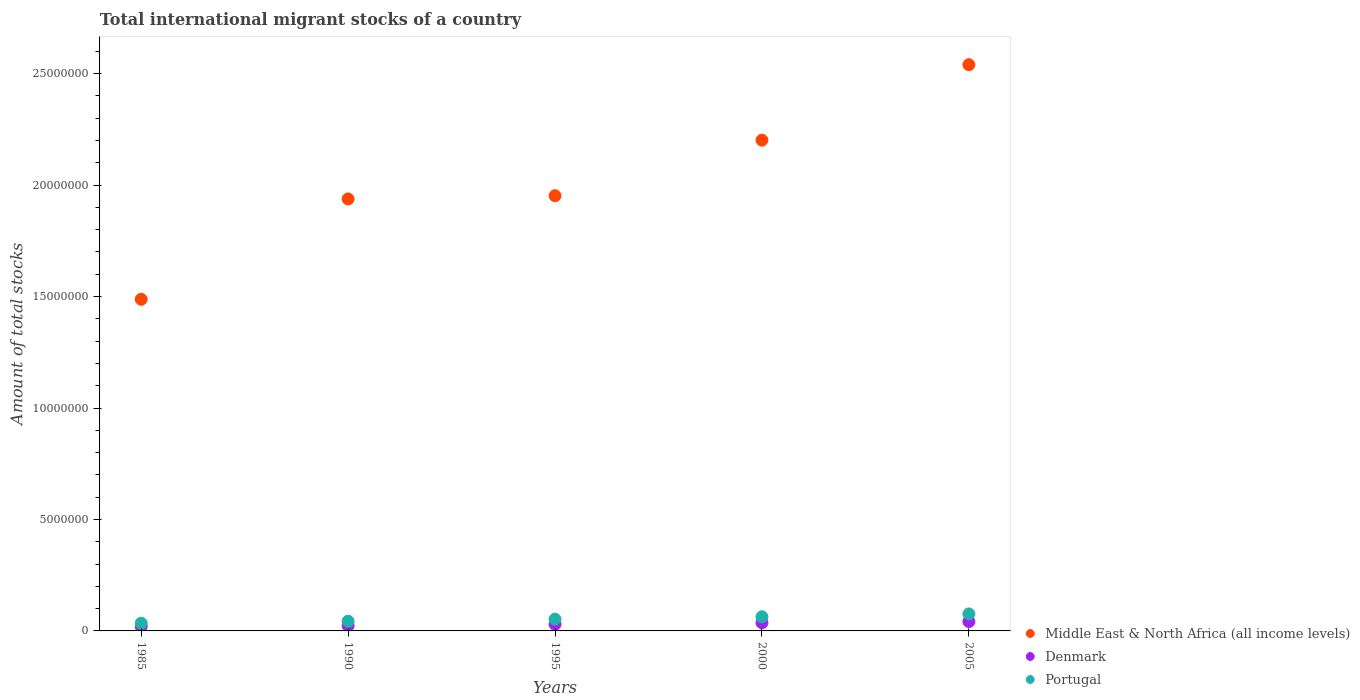How many different coloured dotlines are there?
Provide a short and direct response. 3. Is the number of dotlines equal to the number of legend labels?
Your answer should be compact. Yes. What is the amount of total stocks in in Middle East & North Africa (all income levels) in 1995?
Offer a very short reply. 1.95e+07. Across all years, what is the maximum amount of total stocks in in Denmark?
Make the answer very short. 4.21e+05. Across all years, what is the minimum amount of total stocks in in Middle East & North Africa (all income levels)?
Offer a very short reply. 1.49e+07. In which year was the amount of total stocks in in Portugal maximum?
Make the answer very short. 2005. In which year was the amount of total stocks in in Middle East & North Africa (all income levels) minimum?
Your answer should be compact. 1985. What is the total amount of total stocks in in Middle East & North Africa (all income levels) in the graph?
Ensure brevity in your answer.  1.01e+08. What is the difference between the amount of total stocks in in Portugal in 1990 and that in 2005?
Your answer should be very brief. -3.28e+05. What is the difference between the amount of total stocks in in Middle East & North Africa (all income levels) in 1985 and the amount of total stocks in in Portugal in 1995?
Ensure brevity in your answer.  1.43e+07. What is the average amount of total stocks in in Denmark per year?
Provide a short and direct response. 3.04e+05. In the year 2000, what is the difference between the amount of total stocks in in Portugal and amount of total stocks in in Middle East & North Africa (all income levels)?
Keep it short and to the point. -2.14e+07. In how many years, is the amount of total stocks in in Portugal greater than 16000000?
Your answer should be compact. 0. What is the ratio of the amount of total stocks in in Denmark in 1985 to that in 2000?
Your response must be concise. 0.53. Is the amount of total stocks in in Middle East & North Africa (all income levels) in 1985 less than that in 1995?
Your answer should be compact. Yes. What is the difference between the highest and the second highest amount of total stocks in in Denmark?
Give a very brief answer. 4.98e+04. What is the difference between the highest and the lowest amount of total stocks in in Middle East & North Africa (all income levels)?
Your answer should be compact. 1.05e+07. Is the sum of the amount of total stocks in in Portugal in 2000 and 2005 greater than the maximum amount of total stocks in in Middle East & North Africa (all income levels) across all years?
Offer a terse response. No. Are the values on the major ticks of Y-axis written in scientific E-notation?
Your response must be concise. No. Does the graph contain any zero values?
Ensure brevity in your answer.  No. Does the graph contain grids?
Your response must be concise. No. Where does the legend appear in the graph?
Your response must be concise. Bottom right. How many legend labels are there?
Ensure brevity in your answer.  3. What is the title of the graph?
Make the answer very short. Total international migrant stocks of a country. Does "Brazil" appear as one of the legend labels in the graph?
Your answer should be very brief. No. What is the label or title of the X-axis?
Your answer should be very brief. Years. What is the label or title of the Y-axis?
Ensure brevity in your answer.  Amount of total stocks. What is the Amount of total stocks of Middle East & North Africa (all income levels) in 1985?
Offer a very short reply. 1.49e+07. What is the Amount of total stocks of Denmark in 1985?
Keep it short and to the point. 1.96e+05. What is the Amount of total stocks in Portugal in 1985?
Your answer should be very brief. 3.46e+05. What is the Amount of total stocks of Middle East & North Africa (all income levels) in 1990?
Provide a succinct answer. 1.94e+07. What is the Amount of total stocks of Denmark in 1990?
Offer a terse response. 2.35e+05. What is the Amount of total stocks in Portugal in 1990?
Your response must be concise. 4.36e+05. What is the Amount of total stocks of Middle East & North Africa (all income levels) in 1995?
Provide a succinct answer. 1.95e+07. What is the Amount of total stocks of Denmark in 1995?
Offer a terse response. 2.97e+05. What is the Amount of total stocks of Portugal in 1995?
Your answer should be very brief. 5.28e+05. What is the Amount of total stocks of Middle East & North Africa (all income levels) in 2000?
Keep it short and to the point. 2.20e+07. What is the Amount of total stocks in Denmark in 2000?
Make the answer very short. 3.71e+05. What is the Amount of total stocks in Portugal in 2000?
Offer a very short reply. 6.35e+05. What is the Amount of total stocks in Middle East & North Africa (all income levels) in 2005?
Offer a terse response. 2.54e+07. What is the Amount of total stocks in Denmark in 2005?
Your answer should be very brief. 4.21e+05. What is the Amount of total stocks in Portugal in 2005?
Keep it short and to the point. 7.64e+05. Across all years, what is the maximum Amount of total stocks in Middle East & North Africa (all income levels)?
Make the answer very short. 2.54e+07. Across all years, what is the maximum Amount of total stocks of Denmark?
Keep it short and to the point. 4.21e+05. Across all years, what is the maximum Amount of total stocks in Portugal?
Make the answer very short. 7.64e+05. Across all years, what is the minimum Amount of total stocks in Middle East & North Africa (all income levels)?
Your answer should be very brief. 1.49e+07. Across all years, what is the minimum Amount of total stocks of Denmark?
Your response must be concise. 1.96e+05. Across all years, what is the minimum Amount of total stocks of Portugal?
Your answer should be very brief. 3.46e+05. What is the total Amount of total stocks in Middle East & North Africa (all income levels) in the graph?
Provide a short and direct response. 1.01e+08. What is the total Amount of total stocks in Denmark in the graph?
Keep it short and to the point. 1.52e+06. What is the total Amount of total stocks in Portugal in the graph?
Offer a terse response. 2.71e+06. What is the difference between the Amount of total stocks in Middle East & North Africa (all income levels) in 1985 and that in 1990?
Your answer should be very brief. -4.50e+06. What is the difference between the Amount of total stocks in Denmark in 1985 and that in 1990?
Provide a short and direct response. -3.94e+04. What is the difference between the Amount of total stocks in Portugal in 1985 and that in 1990?
Keep it short and to the point. -8.96e+04. What is the difference between the Amount of total stocks in Middle East & North Africa (all income levels) in 1985 and that in 1995?
Your answer should be very brief. -4.65e+06. What is the difference between the Amount of total stocks of Denmark in 1985 and that in 1995?
Ensure brevity in your answer.  -1.02e+05. What is the difference between the Amount of total stocks of Portugal in 1985 and that in 1995?
Your response must be concise. -1.82e+05. What is the difference between the Amount of total stocks of Middle East & North Africa (all income levels) in 1985 and that in 2000?
Provide a succinct answer. -7.14e+06. What is the difference between the Amount of total stocks of Denmark in 1985 and that in 2000?
Offer a very short reply. -1.75e+05. What is the difference between the Amount of total stocks in Portugal in 1985 and that in 2000?
Make the answer very short. -2.89e+05. What is the difference between the Amount of total stocks in Middle East & North Africa (all income levels) in 1985 and that in 2005?
Ensure brevity in your answer.  -1.05e+07. What is the difference between the Amount of total stocks of Denmark in 1985 and that in 2005?
Provide a succinct answer. -2.25e+05. What is the difference between the Amount of total stocks in Portugal in 1985 and that in 2005?
Give a very brief answer. -4.18e+05. What is the difference between the Amount of total stocks in Middle East & North Africa (all income levels) in 1990 and that in 1995?
Your answer should be compact. -1.44e+05. What is the difference between the Amount of total stocks in Denmark in 1990 and that in 1995?
Give a very brief answer. -6.22e+04. What is the difference between the Amount of total stocks of Portugal in 1990 and that in 1995?
Your response must be concise. -9.21e+04. What is the difference between the Amount of total stocks of Middle East & North Africa (all income levels) in 1990 and that in 2000?
Keep it short and to the point. -2.64e+06. What is the difference between the Amount of total stocks in Denmark in 1990 and that in 2000?
Provide a short and direct response. -1.36e+05. What is the difference between the Amount of total stocks of Portugal in 1990 and that in 2000?
Ensure brevity in your answer.  -1.99e+05. What is the difference between the Amount of total stocks of Middle East & North Africa (all income levels) in 1990 and that in 2005?
Your answer should be compact. -6.02e+06. What is the difference between the Amount of total stocks in Denmark in 1990 and that in 2005?
Provide a succinct answer. -1.86e+05. What is the difference between the Amount of total stocks of Portugal in 1990 and that in 2005?
Make the answer very short. -3.28e+05. What is the difference between the Amount of total stocks in Middle East & North Africa (all income levels) in 1995 and that in 2000?
Ensure brevity in your answer.  -2.49e+06. What is the difference between the Amount of total stocks in Denmark in 1995 and that in 2000?
Your answer should be very brief. -7.36e+04. What is the difference between the Amount of total stocks in Portugal in 1995 and that in 2000?
Offer a terse response. -1.07e+05. What is the difference between the Amount of total stocks of Middle East & North Africa (all income levels) in 1995 and that in 2005?
Your response must be concise. -5.88e+06. What is the difference between the Amount of total stocks of Denmark in 1995 and that in 2005?
Your answer should be very brief. -1.23e+05. What is the difference between the Amount of total stocks in Portugal in 1995 and that in 2005?
Make the answer very short. -2.36e+05. What is the difference between the Amount of total stocks in Middle East & North Africa (all income levels) in 2000 and that in 2005?
Offer a very short reply. -3.39e+06. What is the difference between the Amount of total stocks in Denmark in 2000 and that in 2005?
Make the answer very short. -4.98e+04. What is the difference between the Amount of total stocks of Portugal in 2000 and that in 2005?
Ensure brevity in your answer.  -1.29e+05. What is the difference between the Amount of total stocks of Middle East & North Africa (all income levels) in 1985 and the Amount of total stocks of Denmark in 1990?
Offer a very short reply. 1.46e+07. What is the difference between the Amount of total stocks in Middle East & North Africa (all income levels) in 1985 and the Amount of total stocks in Portugal in 1990?
Give a very brief answer. 1.44e+07. What is the difference between the Amount of total stocks of Denmark in 1985 and the Amount of total stocks of Portugal in 1990?
Give a very brief answer. -2.40e+05. What is the difference between the Amount of total stocks in Middle East & North Africa (all income levels) in 1985 and the Amount of total stocks in Denmark in 1995?
Ensure brevity in your answer.  1.46e+07. What is the difference between the Amount of total stocks of Middle East & North Africa (all income levels) in 1985 and the Amount of total stocks of Portugal in 1995?
Provide a succinct answer. 1.43e+07. What is the difference between the Amount of total stocks of Denmark in 1985 and the Amount of total stocks of Portugal in 1995?
Give a very brief answer. -3.32e+05. What is the difference between the Amount of total stocks of Middle East & North Africa (all income levels) in 1985 and the Amount of total stocks of Denmark in 2000?
Give a very brief answer. 1.45e+07. What is the difference between the Amount of total stocks in Middle East & North Africa (all income levels) in 1985 and the Amount of total stocks in Portugal in 2000?
Offer a terse response. 1.42e+07. What is the difference between the Amount of total stocks of Denmark in 1985 and the Amount of total stocks of Portugal in 2000?
Keep it short and to the point. -4.39e+05. What is the difference between the Amount of total stocks in Middle East & North Africa (all income levels) in 1985 and the Amount of total stocks in Denmark in 2005?
Give a very brief answer. 1.45e+07. What is the difference between the Amount of total stocks in Middle East & North Africa (all income levels) in 1985 and the Amount of total stocks in Portugal in 2005?
Ensure brevity in your answer.  1.41e+07. What is the difference between the Amount of total stocks in Denmark in 1985 and the Amount of total stocks in Portugal in 2005?
Your answer should be very brief. -5.68e+05. What is the difference between the Amount of total stocks of Middle East & North Africa (all income levels) in 1990 and the Amount of total stocks of Denmark in 1995?
Keep it short and to the point. 1.91e+07. What is the difference between the Amount of total stocks of Middle East & North Africa (all income levels) in 1990 and the Amount of total stocks of Portugal in 1995?
Your response must be concise. 1.89e+07. What is the difference between the Amount of total stocks of Denmark in 1990 and the Amount of total stocks of Portugal in 1995?
Provide a short and direct response. -2.93e+05. What is the difference between the Amount of total stocks of Middle East & North Africa (all income levels) in 1990 and the Amount of total stocks of Denmark in 2000?
Offer a very short reply. 1.90e+07. What is the difference between the Amount of total stocks in Middle East & North Africa (all income levels) in 1990 and the Amount of total stocks in Portugal in 2000?
Give a very brief answer. 1.87e+07. What is the difference between the Amount of total stocks in Denmark in 1990 and the Amount of total stocks in Portugal in 2000?
Make the answer very short. -4.00e+05. What is the difference between the Amount of total stocks of Middle East & North Africa (all income levels) in 1990 and the Amount of total stocks of Denmark in 2005?
Your answer should be compact. 1.90e+07. What is the difference between the Amount of total stocks of Middle East & North Africa (all income levels) in 1990 and the Amount of total stocks of Portugal in 2005?
Offer a terse response. 1.86e+07. What is the difference between the Amount of total stocks in Denmark in 1990 and the Amount of total stocks in Portugal in 2005?
Provide a succinct answer. -5.29e+05. What is the difference between the Amount of total stocks in Middle East & North Africa (all income levels) in 1995 and the Amount of total stocks in Denmark in 2000?
Your answer should be very brief. 1.92e+07. What is the difference between the Amount of total stocks in Middle East & North Africa (all income levels) in 1995 and the Amount of total stocks in Portugal in 2000?
Ensure brevity in your answer.  1.89e+07. What is the difference between the Amount of total stocks of Denmark in 1995 and the Amount of total stocks of Portugal in 2000?
Your response must be concise. -3.38e+05. What is the difference between the Amount of total stocks in Middle East & North Africa (all income levels) in 1995 and the Amount of total stocks in Denmark in 2005?
Provide a succinct answer. 1.91e+07. What is the difference between the Amount of total stocks in Middle East & North Africa (all income levels) in 1995 and the Amount of total stocks in Portugal in 2005?
Offer a terse response. 1.88e+07. What is the difference between the Amount of total stocks of Denmark in 1995 and the Amount of total stocks of Portugal in 2005?
Your answer should be very brief. -4.66e+05. What is the difference between the Amount of total stocks of Middle East & North Africa (all income levels) in 2000 and the Amount of total stocks of Denmark in 2005?
Keep it short and to the point. 2.16e+07. What is the difference between the Amount of total stocks in Middle East & North Africa (all income levels) in 2000 and the Amount of total stocks in Portugal in 2005?
Provide a short and direct response. 2.13e+07. What is the difference between the Amount of total stocks of Denmark in 2000 and the Amount of total stocks of Portugal in 2005?
Keep it short and to the point. -3.93e+05. What is the average Amount of total stocks of Middle East & North Africa (all income levels) per year?
Offer a very short reply. 2.02e+07. What is the average Amount of total stocks in Denmark per year?
Make the answer very short. 3.04e+05. What is the average Amount of total stocks of Portugal per year?
Give a very brief answer. 5.42e+05. In the year 1985, what is the difference between the Amount of total stocks in Middle East & North Africa (all income levels) and Amount of total stocks in Denmark?
Make the answer very short. 1.47e+07. In the year 1985, what is the difference between the Amount of total stocks of Middle East & North Africa (all income levels) and Amount of total stocks of Portugal?
Your response must be concise. 1.45e+07. In the year 1985, what is the difference between the Amount of total stocks of Denmark and Amount of total stocks of Portugal?
Your answer should be compact. -1.50e+05. In the year 1990, what is the difference between the Amount of total stocks in Middle East & North Africa (all income levels) and Amount of total stocks in Denmark?
Offer a terse response. 1.91e+07. In the year 1990, what is the difference between the Amount of total stocks of Middle East & North Africa (all income levels) and Amount of total stocks of Portugal?
Provide a succinct answer. 1.89e+07. In the year 1990, what is the difference between the Amount of total stocks of Denmark and Amount of total stocks of Portugal?
Make the answer very short. -2.01e+05. In the year 1995, what is the difference between the Amount of total stocks in Middle East & North Africa (all income levels) and Amount of total stocks in Denmark?
Offer a very short reply. 1.92e+07. In the year 1995, what is the difference between the Amount of total stocks in Middle East & North Africa (all income levels) and Amount of total stocks in Portugal?
Give a very brief answer. 1.90e+07. In the year 1995, what is the difference between the Amount of total stocks of Denmark and Amount of total stocks of Portugal?
Keep it short and to the point. -2.31e+05. In the year 2000, what is the difference between the Amount of total stocks of Middle East & North Africa (all income levels) and Amount of total stocks of Denmark?
Ensure brevity in your answer.  2.16e+07. In the year 2000, what is the difference between the Amount of total stocks of Middle East & North Africa (all income levels) and Amount of total stocks of Portugal?
Offer a very short reply. 2.14e+07. In the year 2000, what is the difference between the Amount of total stocks in Denmark and Amount of total stocks in Portugal?
Offer a very short reply. -2.64e+05. In the year 2005, what is the difference between the Amount of total stocks of Middle East & North Africa (all income levels) and Amount of total stocks of Denmark?
Your answer should be compact. 2.50e+07. In the year 2005, what is the difference between the Amount of total stocks of Middle East & North Africa (all income levels) and Amount of total stocks of Portugal?
Offer a very short reply. 2.46e+07. In the year 2005, what is the difference between the Amount of total stocks in Denmark and Amount of total stocks in Portugal?
Your response must be concise. -3.43e+05. What is the ratio of the Amount of total stocks in Middle East & North Africa (all income levels) in 1985 to that in 1990?
Your answer should be compact. 0.77. What is the ratio of the Amount of total stocks in Denmark in 1985 to that in 1990?
Ensure brevity in your answer.  0.83. What is the ratio of the Amount of total stocks in Portugal in 1985 to that in 1990?
Your response must be concise. 0.79. What is the ratio of the Amount of total stocks of Middle East & North Africa (all income levels) in 1985 to that in 1995?
Give a very brief answer. 0.76. What is the ratio of the Amount of total stocks of Denmark in 1985 to that in 1995?
Keep it short and to the point. 0.66. What is the ratio of the Amount of total stocks in Portugal in 1985 to that in 1995?
Offer a terse response. 0.66. What is the ratio of the Amount of total stocks in Middle East & North Africa (all income levels) in 1985 to that in 2000?
Provide a succinct answer. 0.68. What is the ratio of the Amount of total stocks of Denmark in 1985 to that in 2000?
Your answer should be compact. 0.53. What is the ratio of the Amount of total stocks of Portugal in 1985 to that in 2000?
Your answer should be compact. 0.55. What is the ratio of the Amount of total stocks in Middle East & North Africa (all income levels) in 1985 to that in 2005?
Keep it short and to the point. 0.59. What is the ratio of the Amount of total stocks in Denmark in 1985 to that in 2005?
Make the answer very short. 0.47. What is the ratio of the Amount of total stocks in Portugal in 1985 to that in 2005?
Offer a terse response. 0.45. What is the ratio of the Amount of total stocks in Middle East & North Africa (all income levels) in 1990 to that in 1995?
Your response must be concise. 0.99. What is the ratio of the Amount of total stocks in Denmark in 1990 to that in 1995?
Your answer should be very brief. 0.79. What is the ratio of the Amount of total stocks in Portugal in 1990 to that in 1995?
Your response must be concise. 0.83. What is the ratio of the Amount of total stocks in Middle East & North Africa (all income levels) in 1990 to that in 2000?
Your answer should be very brief. 0.88. What is the ratio of the Amount of total stocks of Denmark in 1990 to that in 2000?
Provide a short and direct response. 0.63. What is the ratio of the Amount of total stocks in Portugal in 1990 to that in 2000?
Your response must be concise. 0.69. What is the ratio of the Amount of total stocks of Middle East & North Africa (all income levels) in 1990 to that in 2005?
Your answer should be very brief. 0.76. What is the ratio of the Amount of total stocks of Denmark in 1990 to that in 2005?
Your response must be concise. 0.56. What is the ratio of the Amount of total stocks in Portugal in 1990 to that in 2005?
Your answer should be very brief. 0.57. What is the ratio of the Amount of total stocks of Middle East & North Africa (all income levels) in 1995 to that in 2000?
Provide a short and direct response. 0.89. What is the ratio of the Amount of total stocks of Denmark in 1995 to that in 2000?
Make the answer very short. 0.8. What is the ratio of the Amount of total stocks in Portugal in 1995 to that in 2000?
Offer a terse response. 0.83. What is the ratio of the Amount of total stocks of Middle East & North Africa (all income levels) in 1995 to that in 2005?
Offer a terse response. 0.77. What is the ratio of the Amount of total stocks in Denmark in 1995 to that in 2005?
Make the answer very short. 0.71. What is the ratio of the Amount of total stocks in Portugal in 1995 to that in 2005?
Your answer should be very brief. 0.69. What is the ratio of the Amount of total stocks of Middle East & North Africa (all income levels) in 2000 to that in 2005?
Your answer should be compact. 0.87. What is the ratio of the Amount of total stocks of Denmark in 2000 to that in 2005?
Your answer should be very brief. 0.88. What is the ratio of the Amount of total stocks of Portugal in 2000 to that in 2005?
Offer a terse response. 0.83. What is the difference between the highest and the second highest Amount of total stocks in Middle East & North Africa (all income levels)?
Make the answer very short. 3.39e+06. What is the difference between the highest and the second highest Amount of total stocks in Denmark?
Offer a very short reply. 4.98e+04. What is the difference between the highest and the second highest Amount of total stocks of Portugal?
Your answer should be very brief. 1.29e+05. What is the difference between the highest and the lowest Amount of total stocks in Middle East & North Africa (all income levels)?
Offer a very short reply. 1.05e+07. What is the difference between the highest and the lowest Amount of total stocks in Denmark?
Give a very brief answer. 2.25e+05. What is the difference between the highest and the lowest Amount of total stocks of Portugal?
Provide a short and direct response. 4.18e+05. 